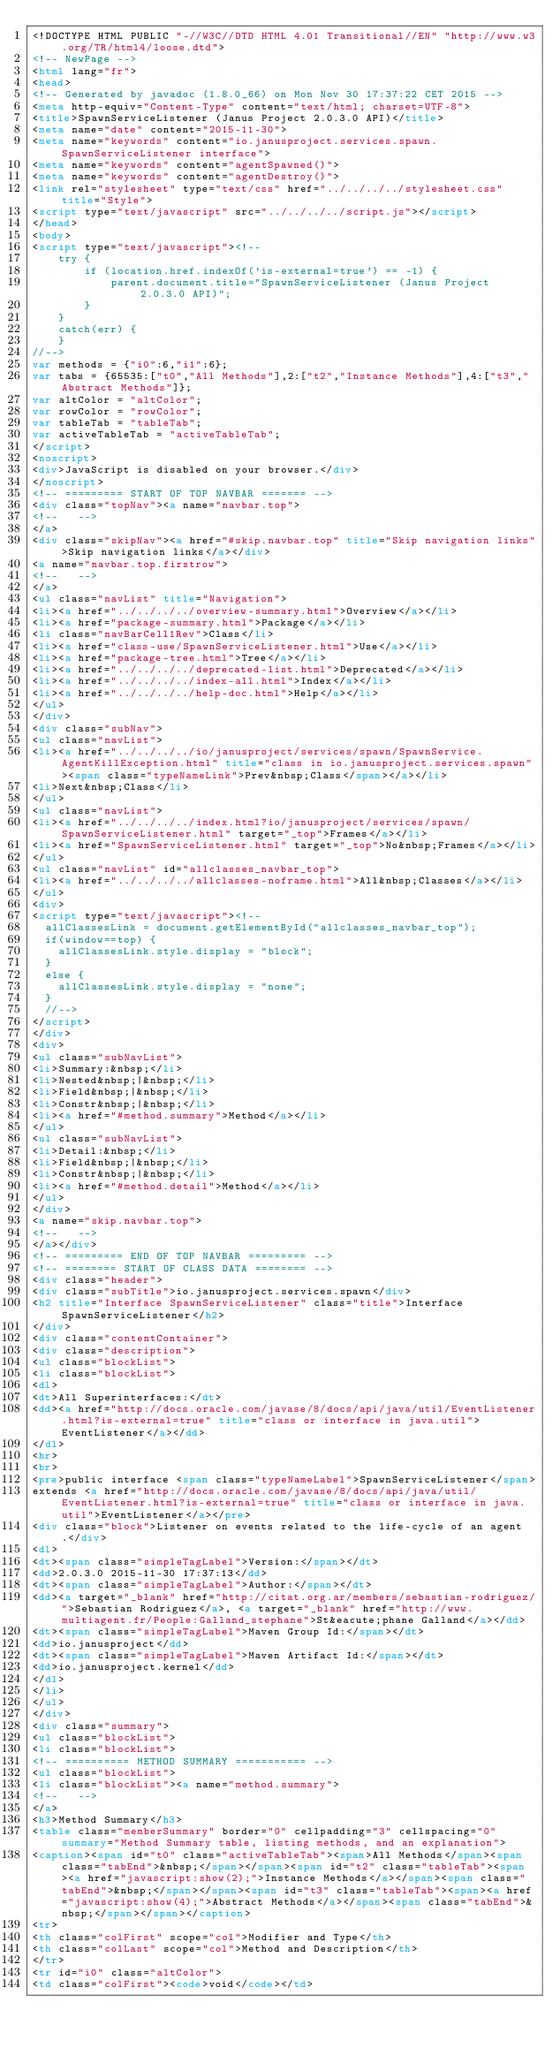Convert code to text. <code><loc_0><loc_0><loc_500><loc_500><_HTML_><!DOCTYPE HTML PUBLIC "-//W3C//DTD HTML 4.01 Transitional//EN" "http://www.w3.org/TR/html4/loose.dtd">
<!-- NewPage -->
<html lang="fr">
<head>
<!-- Generated by javadoc (1.8.0_66) on Mon Nov 30 17:37:22 CET 2015 -->
<meta http-equiv="Content-Type" content="text/html; charset=UTF-8">
<title>SpawnServiceListener (Janus Project 2.0.3.0 API)</title>
<meta name="date" content="2015-11-30">
<meta name="keywords" content="io.janusproject.services.spawn.SpawnServiceListener interface">
<meta name="keywords" content="agentSpawned()">
<meta name="keywords" content="agentDestroy()">
<link rel="stylesheet" type="text/css" href="../../../../stylesheet.css" title="Style">
<script type="text/javascript" src="../../../../script.js"></script>
</head>
<body>
<script type="text/javascript"><!--
    try {
        if (location.href.indexOf('is-external=true') == -1) {
            parent.document.title="SpawnServiceListener (Janus Project 2.0.3.0 API)";
        }
    }
    catch(err) {
    }
//-->
var methods = {"i0":6,"i1":6};
var tabs = {65535:["t0","All Methods"],2:["t2","Instance Methods"],4:["t3","Abstract Methods"]};
var altColor = "altColor";
var rowColor = "rowColor";
var tableTab = "tableTab";
var activeTableTab = "activeTableTab";
</script>
<noscript>
<div>JavaScript is disabled on your browser.</div>
</noscript>
<!-- ========= START OF TOP NAVBAR ======= -->
<div class="topNav"><a name="navbar.top">
<!--   -->
</a>
<div class="skipNav"><a href="#skip.navbar.top" title="Skip navigation links">Skip navigation links</a></div>
<a name="navbar.top.firstrow">
<!--   -->
</a>
<ul class="navList" title="Navigation">
<li><a href="../../../../overview-summary.html">Overview</a></li>
<li><a href="package-summary.html">Package</a></li>
<li class="navBarCell1Rev">Class</li>
<li><a href="class-use/SpawnServiceListener.html">Use</a></li>
<li><a href="package-tree.html">Tree</a></li>
<li><a href="../../../../deprecated-list.html">Deprecated</a></li>
<li><a href="../../../../index-all.html">Index</a></li>
<li><a href="../../../../help-doc.html">Help</a></li>
</ul>
</div>
<div class="subNav">
<ul class="navList">
<li><a href="../../../../io/janusproject/services/spawn/SpawnService.AgentKillException.html" title="class in io.janusproject.services.spawn"><span class="typeNameLink">Prev&nbsp;Class</span></a></li>
<li>Next&nbsp;Class</li>
</ul>
<ul class="navList">
<li><a href="../../../../index.html?io/janusproject/services/spawn/SpawnServiceListener.html" target="_top">Frames</a></li>
<li><a href="SpawnServiceListener.html" target="_top">No&nbsp;Frames</a></li>
</ul>
<ul class="navList" id="allclasses_navbar_top">
<li><a href="../../../../allclasses-noframe.html">All&nbsp;Classes</a></li>
</ul>
<div>
<script type="text/javascript"><!--
  allClassesLink = document.getElementById("allclasses_navbar_top");
  if(window==top) {
    allClassesLink.style.display = "block";
  }
  else {
    allClassesLink.style.display = "none";
  }
  //-->
</script>
</div>
<div>
<ul class="subNavList">
<li>Summary:&nbsp;</li>
<li>Nested&nbsp;|&nbsp;</li>
<li>Field&nbsp;|&nbsp;</li>
<li>Constr&nbsp;|&nbsp;</li>
<li><a href="#method.summary">Method</a></li>
</ul>
<ul class="subNavList">
<li>Detail:&nbsp;</li>
<li>Field&nbsp;|&nbsp;</li>
<li>Constr&nbsp;|&nbsp;</li>
<li><a href="#method.detail">Method</a></li>
</ul>
</div>
<a name="skip.navbar.top">
<!--   -->
</a></div>
<!-- ========= END OF TOP NAVBAR ========= -->
<!-- ======== START OF CLASS DATA ======== -->
<div class="header">
<div class="subTitle">io.janusproject.services.spawn</div>
<h2 title="Interface SpawnServiceListener" class="title">Interface SpawnServiceListener</h2>
</div>
<div class="contentContainer">
<div class="description">
<ul class="blockList">
<li class="blockList">
<dl>
<dt>All Superinterfaces:</dt>
<dd><a href="http://docs.oracle.com/javase/8/docs/api/java/util/EventListener.html?is-external=true" title="class or interface in java.util">EventListener</a></dd>
</dl>
<hr>
<br>
<pre>public interface <span class="typeNameLabel">SpawnServiceListener</span>
extends <a href="http://docs.oracle.com/javase/8/docs/api/java/util/EventListener.html?is-external=true" title="class or interface in java.util">EventListener</a></pre>
<div class="block">Listener on events related to the life-cycle of an agent.</div>
<dl>
<dt><span class="simpleTagLabel">Version:</span></dt>
<dd>2.0.3.0 2015-11-30 17:37:13</dd>
<dt><span class="simpleTagLabel">Author:</span></dt>
<dd><a target="_blank" href="http://citat.org.ar/members/sebastian-rodriguez/">Sebastian Rodriguez</a>, <a target="_blank" href="http://www.multiagent.fr/People:Galland_stephane">St&eacute;phane Galland</a></dd>
<dt><span class="simpleTagLabel">Maven Group Id:</span></dt>
<dd>io.janusproject</dd>
<dt><span class="simpleTagLabel">Maven Artifact Id:</span></dt>
<dd>io.janusproject.kernel</dd>
</dl>
</li>
</ul>
</div>
<div class="summary">
<ul class="blockList">
<li class="blockList">
<!-- ========== METHOD SUMMARY =========== -->
<ul class="blockList">
<li class="blockList"><a name="method.summary">
<!--   -->
</a>
<h3>Method Summary</h3>
<table class="memberSummary" border="0" cellpadding="3" cellspacing="0" summary="Method Summary table, listing methods, and an explanation">
<caption><span id="t0" class="activeTableTab"><span>All Methods</span><span class="tabEnd">&nbsp;</span></span><span id="t2" class="tableTab"><span><a href="javascript:show(2);">Instance Methods</a></span><span class="tabEnd">&nbsp;</span></span><span id="t3" class="tableTab"><span><a href="javascript:show(4);">Abstract Methods</a></span><span class="tabEnd">&nbsp;</span></span></caption>
<tr>
<th class="colFirst" scope="col">Modifier and Type</th>
<th class="colLast" scope="col">Method and Description</th>
</tr>
<tr id="i0" class="altColor">
<td class="colFirst"><code>void</code></td></code> 